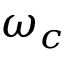Convert formula to latex. <formula><loc_0><loc_0><loc_500><loc_500>\omega _ { c }</formula> 